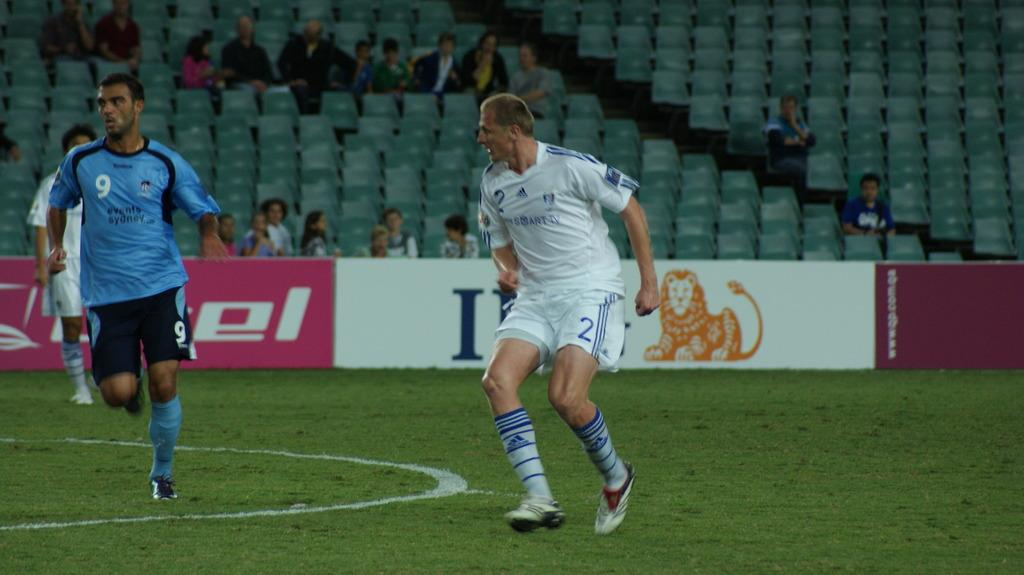<image>
Write a terse but informative summary of the picture. Soccer player wearing number 2 heading towards player number 9. 